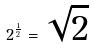Convert formula to latex. <formula><loc_0><loc_0><loc_500><loc_500>2 ^ { \frac { 1 } { 2 } } = \sqrt { 2 }</formula> 